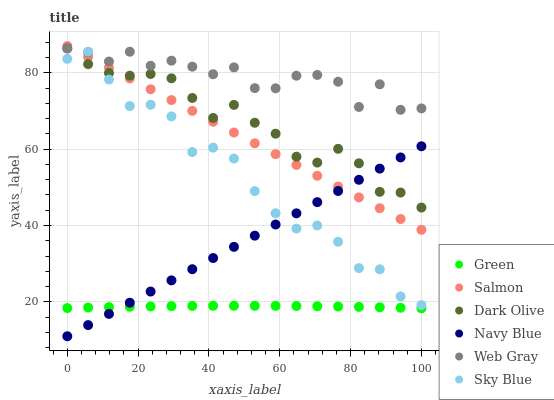Does Green have the minimum area under the curve?
Answer yes or no. Yes. Does Web Gray have the maximum area under the curve?
Answer yes or no. Yes. Does Navy Blue have the minimum area under the curve?
Answer yes or no. No. Does Navy Blue have the maximum area under the curve?
Answer yes or no. No. Is Navy Blue the smoothest?
Answer yes or no. Yes. Is Web Gray the roughest?
Answer yes or no. Yes. Is Dark Olive the smoothest?
Answer yes or no. No. Is Dark Olive the roughest?
Answer yes or no. No. Does Navy Blue have the lowest value?
Answer yes or no. Yes. Does Dark Olive have the lowest value?
Answer yes or no. No. Does Salmon have the highest value?
Answer yes or no. Yes. Does Navy Blue have the highest value?
Answer yes or no. No. Is Green less than Dark Olive?
Answer yes or no. Yes. Is Web Gray greater than Green?
Answer yes or no. Yes. Does Salmon intersect Dark Olive?
Answer yes or no. Yes. Is Salmon less than Dark Olive?
Answer yes or no. No. Is Salmon greater than Dark Olive?
Answer yes or no. No. Does Green intersect Dark Olive?
Answer yes or no. No. 